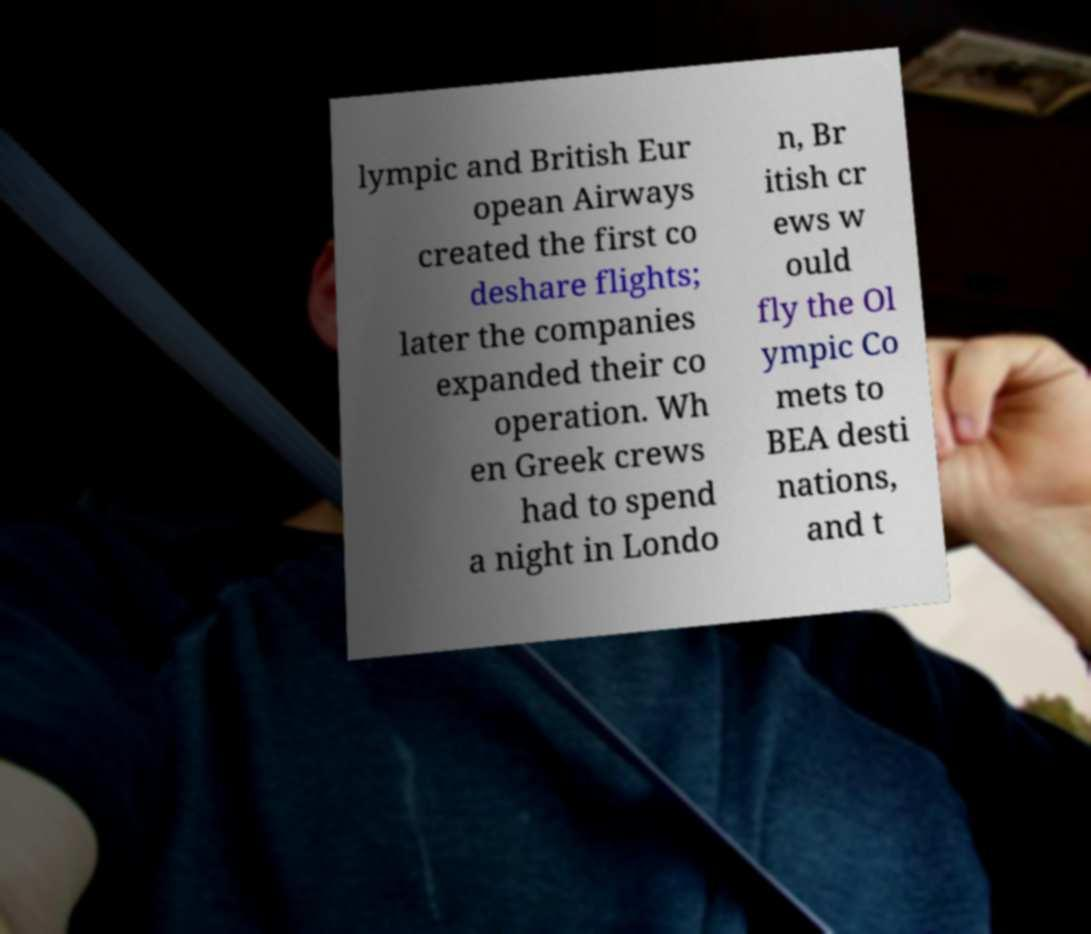Please identify and transcribe the text found in this image. lympic and British Eur opean Airways created the first co deshare flights; later the companies expanded their co operation. Wh en Greek crews had to spend a night in Londo n, Br itish cr ews w ould fly the Ol ympic Co mets to BEA desti nations, and t 